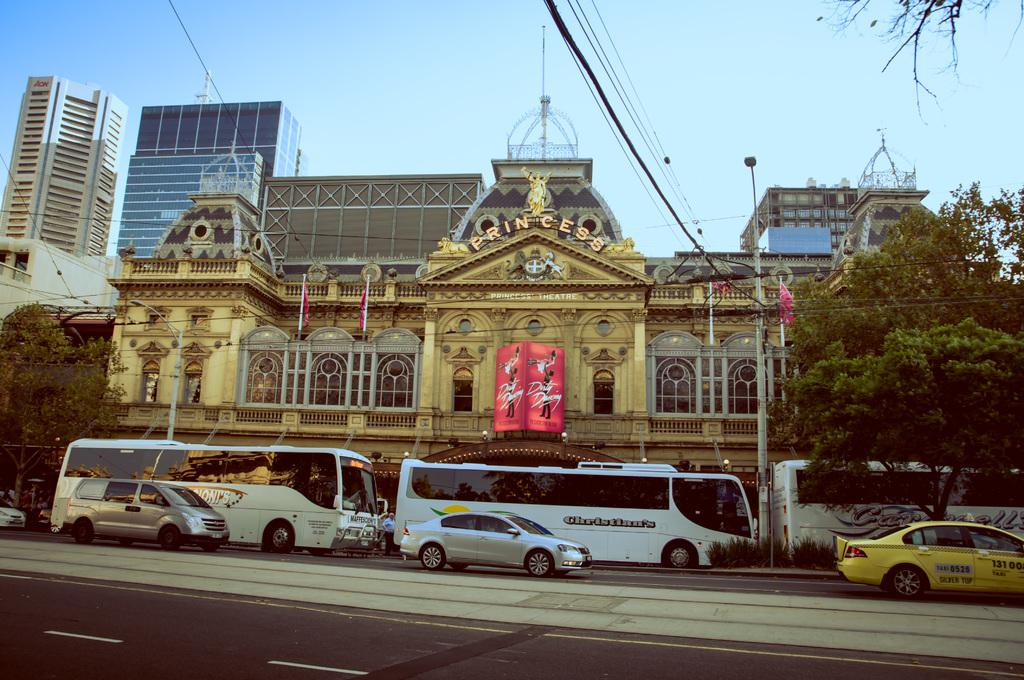<image>
Offer a succinct explanation of the picture presented. A large building that faces the street that appears to be a very old building with PRINCESS in gold written at the top. 